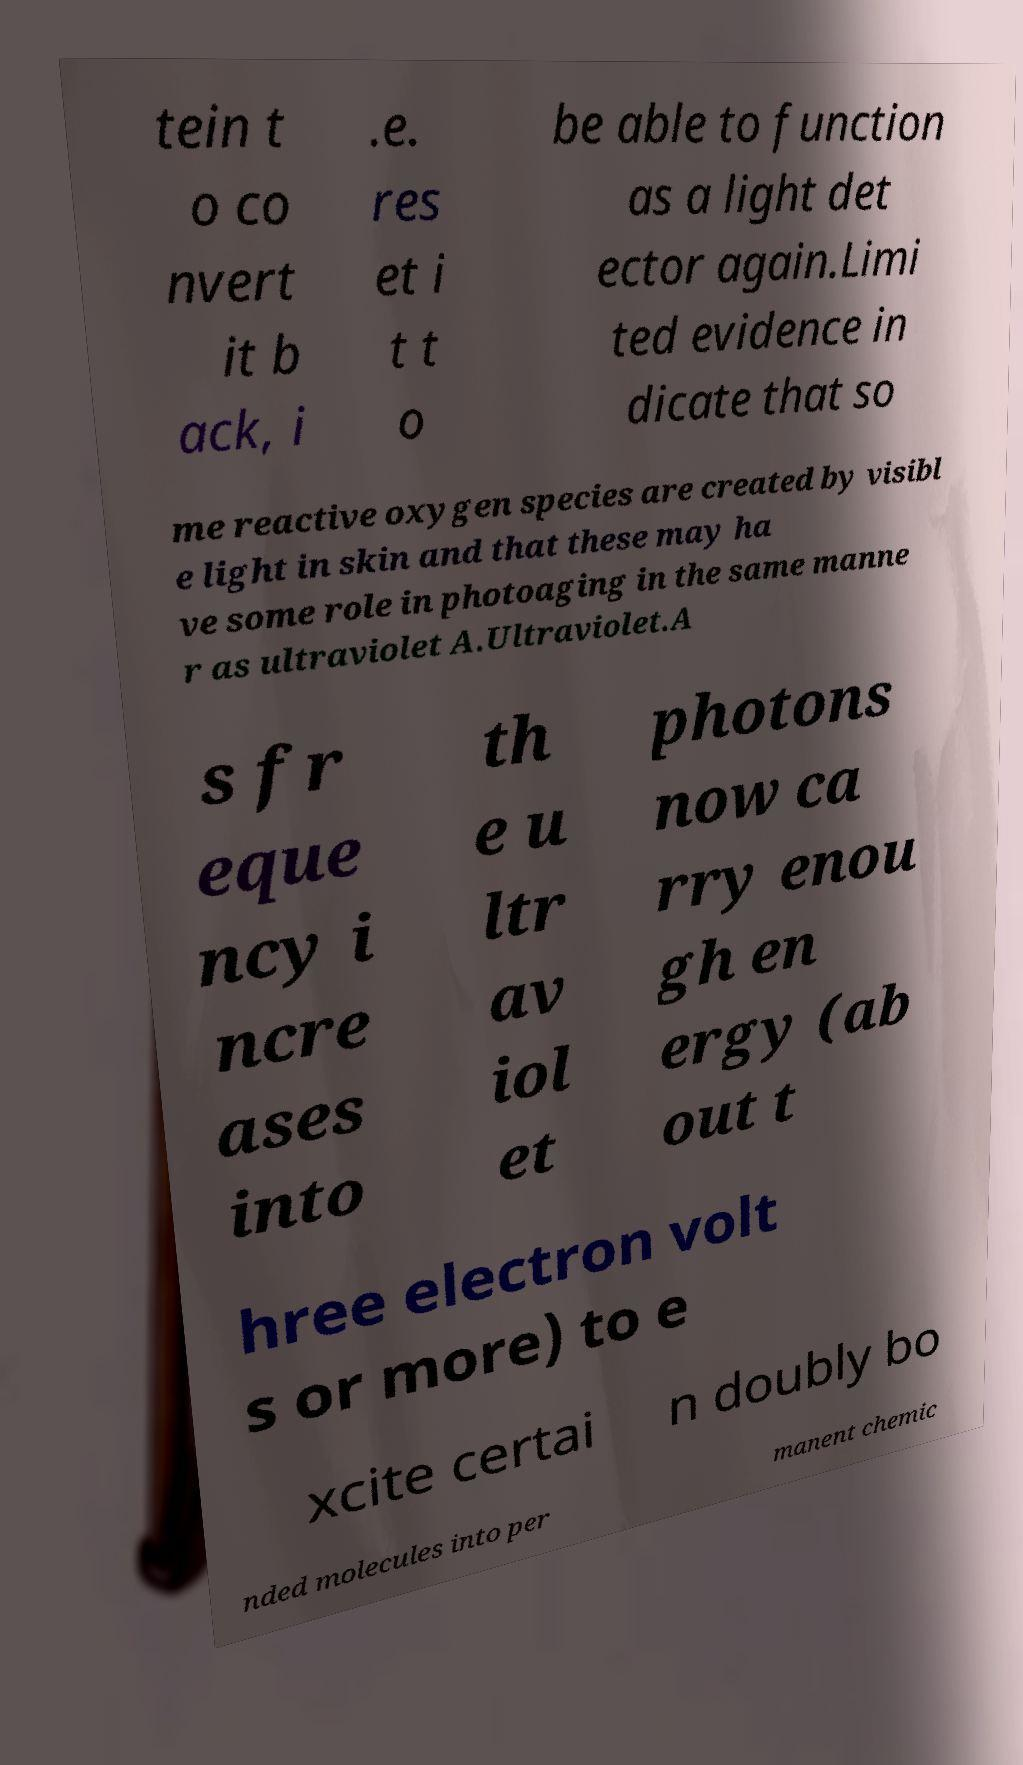Can you accurately transcribe the text from the provided image for me? tein t o co nvert it b ack, i .e. res et i t t o be able to function as a light det ector again.Limi ted evidence in dicate that so me reactive oxygen species are created by visibl e light in skin and that these may ha ve some role in photoaging in the same manne r as ultraviolet A.Ultraviolet.A s fr eque ncy i ncre ases into th e u ltr av iol et photons now ca rry enou gh en ergy (ab out t hree electron volt s or more) to e xcite certai n doubly bo nded molecules into per manent chemic 